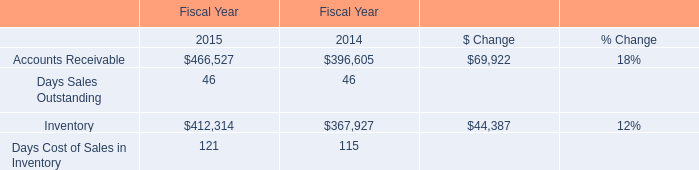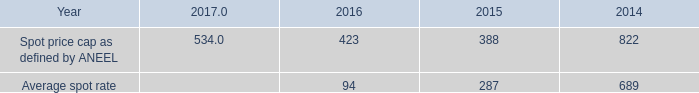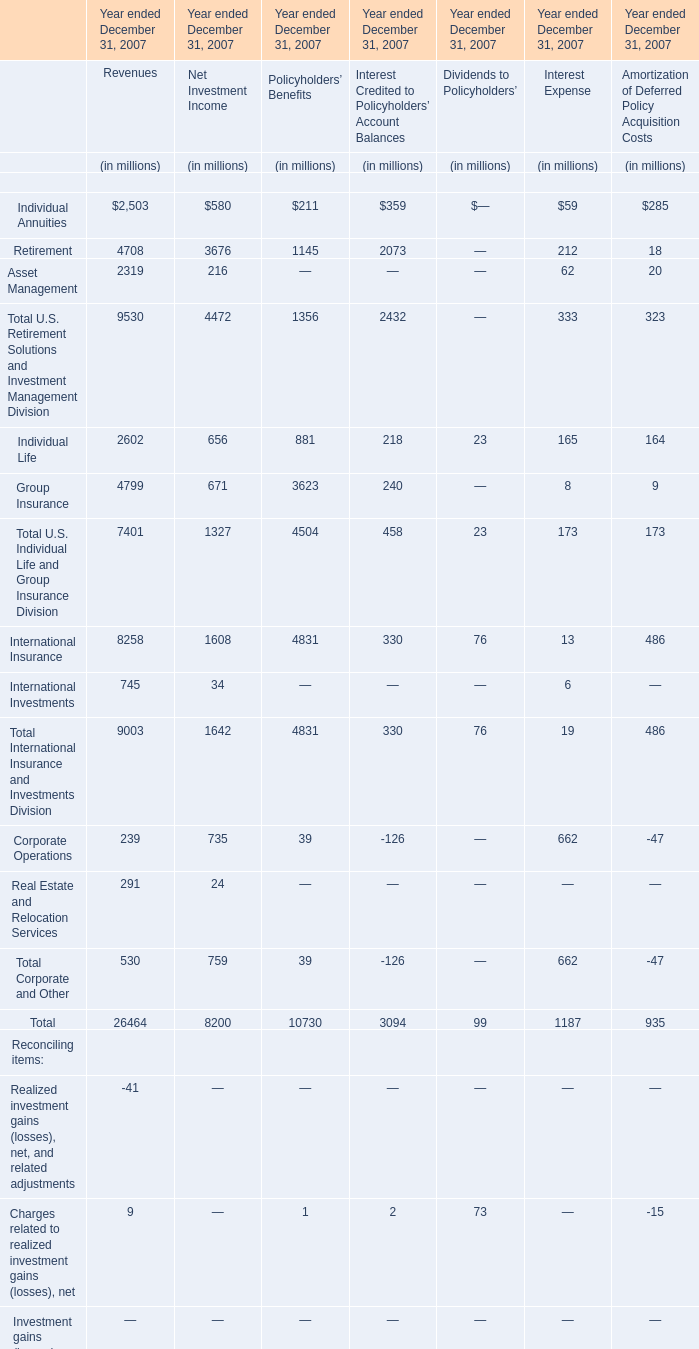What is the average value of International Insurance for Revenues,Net Investment Income, and Policyholders'Benefits? (in million) 
Computations: (((1608 + 4831) + 330) / 3)
Answer: 2256.33333. 